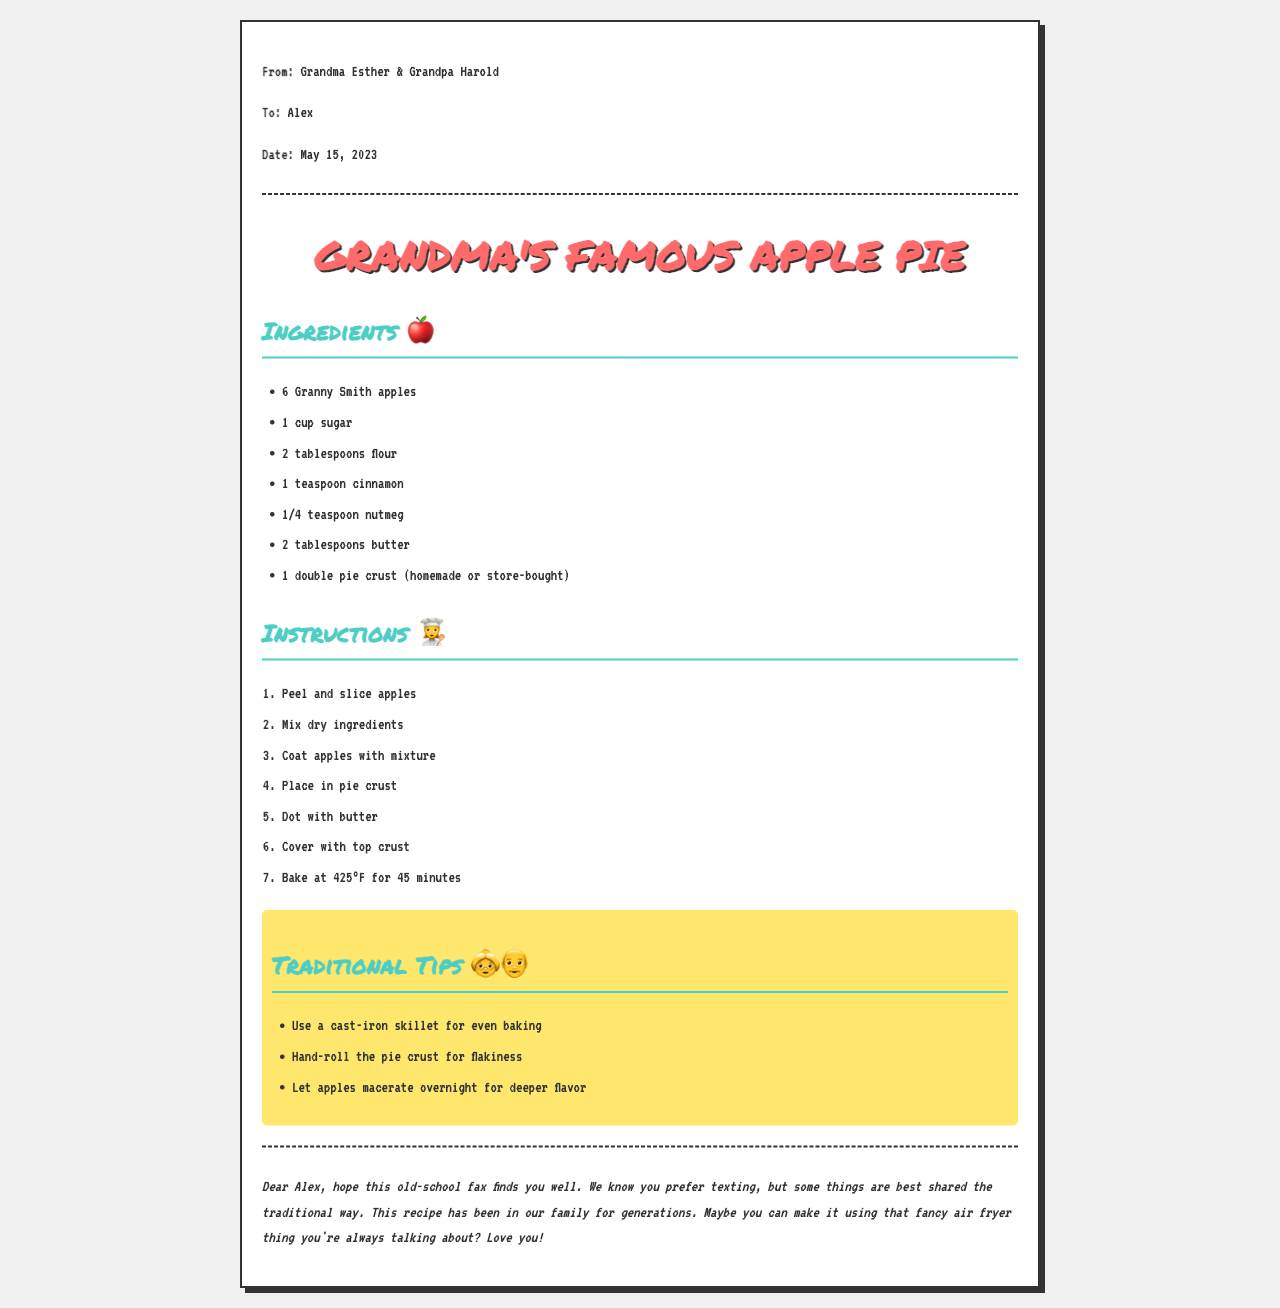what is the name of the recipe? The name of the recipe is titled prominently at the top of the document.
Answer: Grandma's Famous Apple Pie who is the sender of the fax? The sender of the fax is stated in the 'From' section of the document.
Answer: Grandma Esther & Grandpa Harold how many Granny Smith apples are needed? The number of Granny Smith apples is listed in the ingredients section of the document.
Answer: 6 what temperature should the pie be baked at? The baking temperature is provided in the instructions for making the pie.
Answer: 425°F what ingredient helps with the flavor of the apples? One of the ingredients listed that enhances the flavor of the apples is found in the ingredients section.
Answer: cinnamon what is a traditional tip for baking? One of the traditional tips provided indicates a method for better baking.
Answer: Use a cast-iron skillet how is the family recipe conveyed? The method of communication for sharing the recipe is identified in the document.
Answer: Fax who is the recipient of the fax? The recipient is specified in the 'To' section of the document.
Answer: Alex 